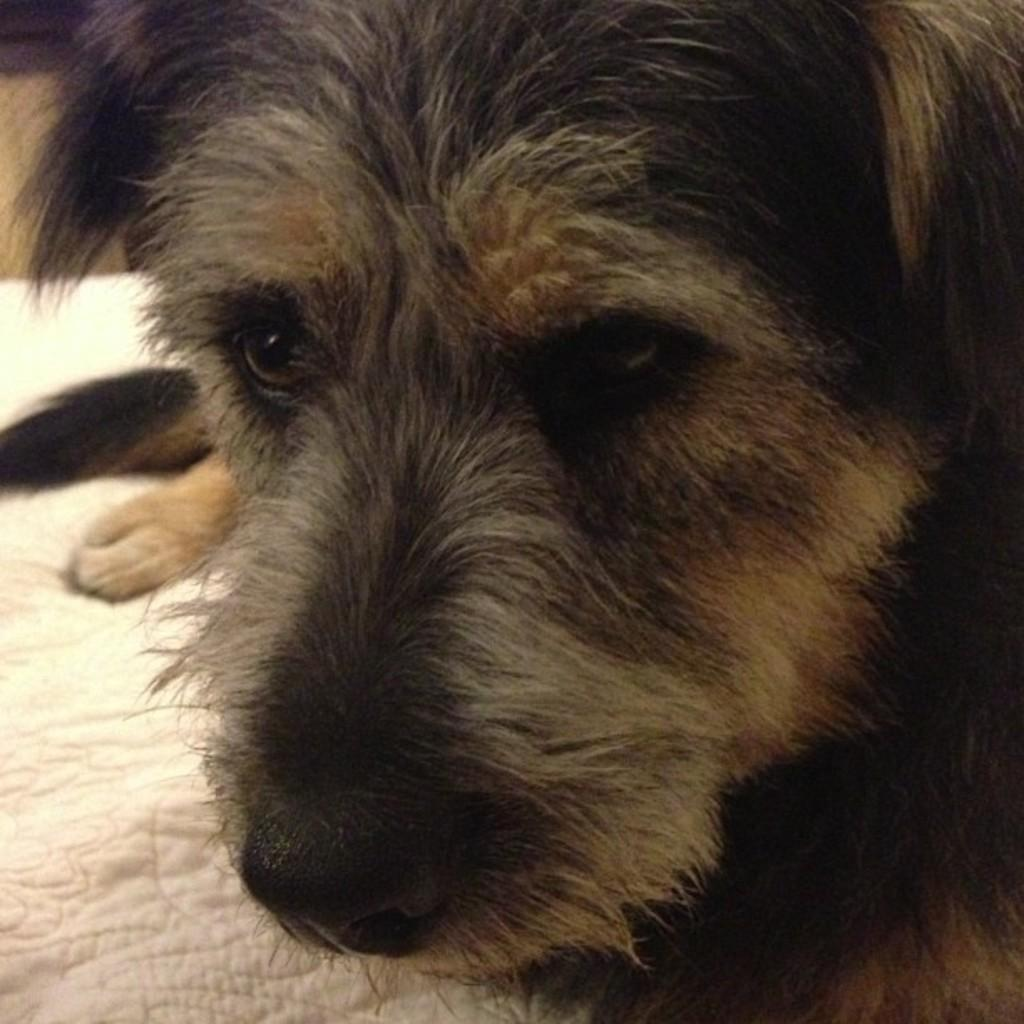What type of animal is in the image? There is a dog in the image. What is the dog positioned on? The dog is on cloth. What type of slave is depicted in the image? There is no slave depicted in the image; it features a dog on cloth. How much money is visible in the image? There is no money present in the image. 